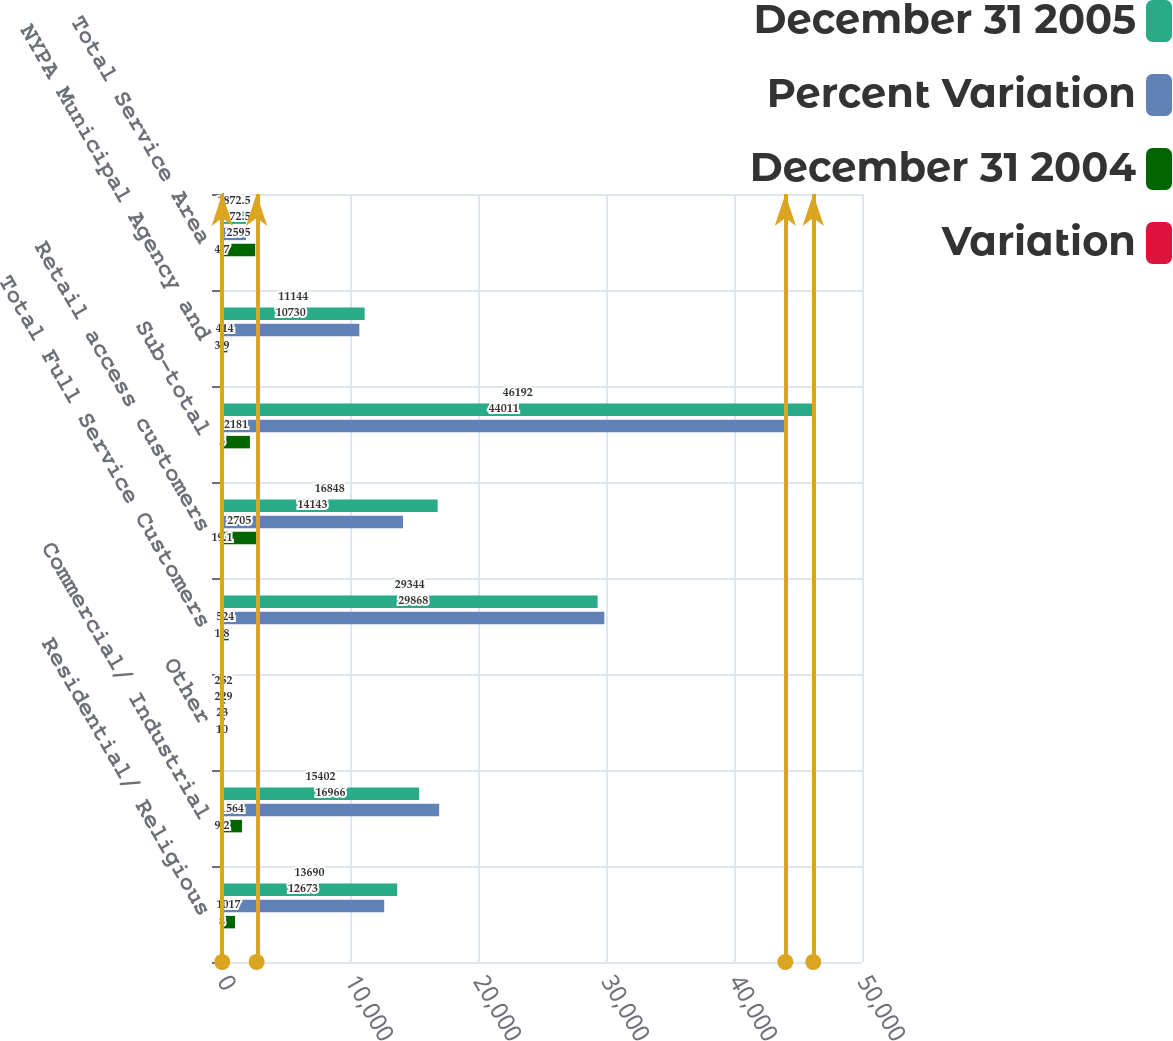Convert chart to OTSL. <chart><loc_0><loc_0><loc_500><loc_500><stacked_bar_chart><ecel><fcel>Residential/ Religious<fcel>Commercial/ Industrial<fcel>Other<fcel>Total Full Service Customers<fcel>Retail access customers<fcel>Sub-total<fcel>NYPA Municipal Agency and<fcel>Total Service Area<nl><fcel>December 31 2005<fcel>13690<fcel>15402<fcel>252<fcel>29344<fcel>16848<fcel>46192<fcel>11144<fcel>1872.5<nl><fcel>Percent Variation<fcel>12673<fcel>16966<fcel>229<fcel>29868<fcel>14143<fcel>44011<fcel>10730<fcel>1872.5<nl><fcel>December 31 2004<fcel>1017<fcel>1564<fcel>23<fcel>524<fcel>2705<fcel>2181<fcel>414<fcel>2595<nl><fcel>Variation<fcel>8<fcel>9.2<fcel>10<fcel>1.8<fcel>19.1<fcel>5<fcel>3.9<fcel>4.7<nl></chart> 